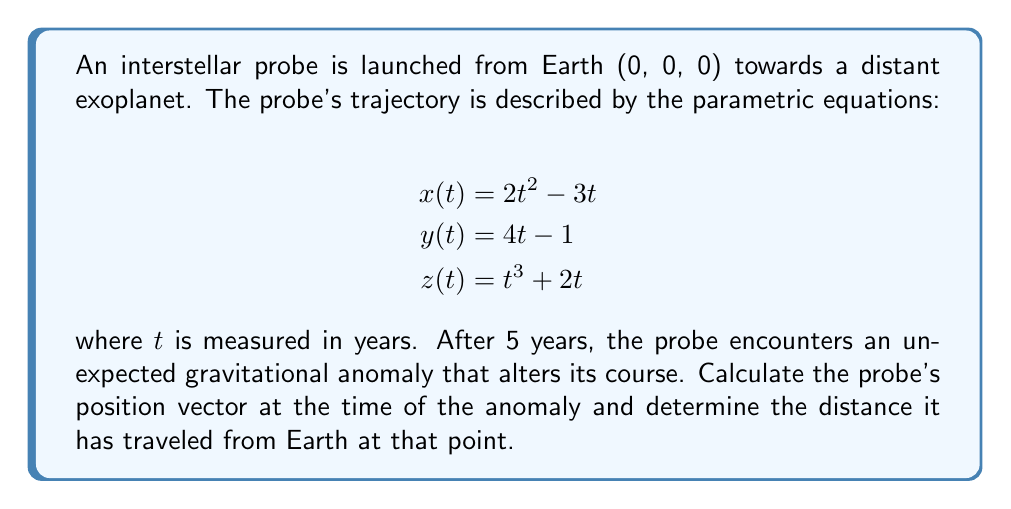Could you help me with this problem? To solve this problem, we'll follow these steps:

1) First, we need to calculate the position of the probe at $t = 5$ years:

   For $x$: $x(5) = 2(5)^2 - 3(5) = 50 - 15 = 35$
   For $y$: $y(5) = 4(5) - 1 = 19$
   For $z$: $z(5) = (5)^3 + 2(5) = 125 + 10 = 135$

   So, the position vector at $t = 5$ is $\vec{r}(5) = (35, 19, 135)$

2) To calculate the distance traveled, we need to find the magnitude of this position vector:

   $$d = \sqrt{x^2 + y^2 + z^2}$$
   $$d = \sqrt{35^2 + 19^2 + 135^2}$$
   $$d = \sqrt{1225 + 361 + 18225}$$
   $$d = \sqrt{19811}$$
   $$d \approx 140.75$$

3) Therefore, the distance traveled by the probe after 5 years is approximately 140.75 units (likely astronomical units or AU, given the interstellar scale).

This result showcases the immense distances involved in interstellar travel, highlighting the challenges faced in deep space exploration and the potential for unexpected phenomena to significantly impact mission trajectories.
Answer: The probe's position vector at the time of the anomaly (5 years after launch) is $(35, 19, 135)$, and it has traveled approximately 140.75 units from Earth. 